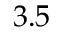<formula> <loc_0><loc_0><loc_500><loc_500>3 . 5</formula> 